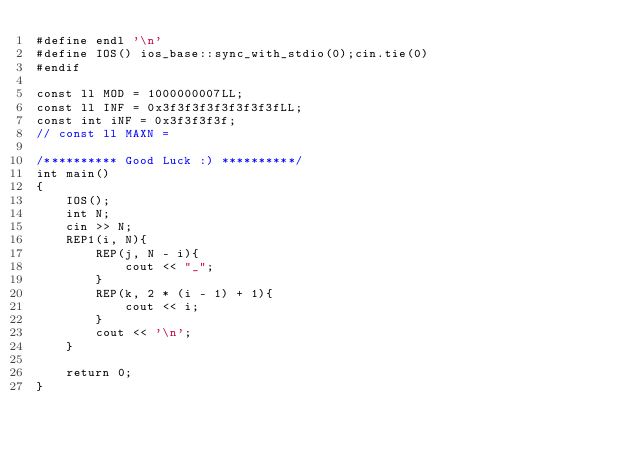<code> <loc_0><loc_0><loc_500><loc_500><_C++_>#define endl '\n'
#define IOS() ios_base::sync_with_stdio(0);cin.tie(0)
#endif

const ll MOD = 1000000007LL;
const ll INF = 0x3f3f3f3f3f3f3f3fLL;
const int iNF = 0x3f3f3f3f;
// const ll MAXN = 

/********** Good Luck :) **********/
int main()
{
    IOS();
    int N;
    cin >> N;
    REP1(i, N){
        REP(j, N - i){
            cout << "_";
        }
        REP(k, 2 * (i - 1) + 1){
            cout << i;
        }
        cout << '\n';
    }
    
    return 0;
}
</code> 